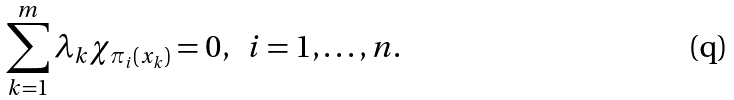Convert formula to latex. <formula><loc_0><loc_0><loc_500><loc_500>\sum _ { k = 1 } ^ { m } \lambda _ { k } \chi _ { \pi _ { i } ( x _ { k } ) } = 0 , \text { \ } i = 1 , \dots , n .</formula> 